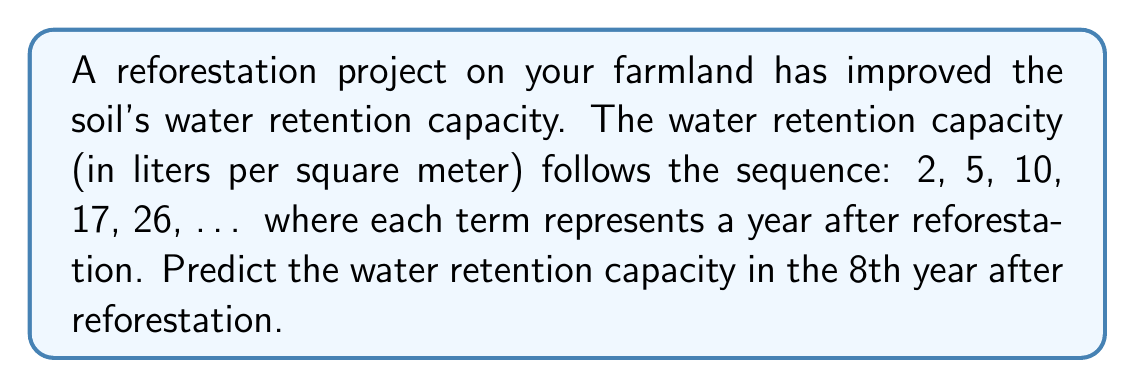Can you answer this question? To solve this problem, let's follow these steps:

1) First, we need to identify the pattern in the given sequence:
   2, 5, 10, 17, 26, ...

2) Let's calculate the differences between consecutive terms:
   5 - 2 = 3
   10 - 5 = 5
   17 - 10 = 7
   26 - 17 = 9

3) We can see that the differences form an arithmetic sequence:
   3, 5, 7, 9, ...
   This sequence has a common difference of 2.

4) This indicates that our original sequence is a quadratic sequence.

5) The general formula for a quadratic sequence is:
   $$a_n = an^2 + bn + c$$
   where $n$ is the term number, and $a$, $b$, and $c$ are constants we need to determine.

6) We can use the first three terms to set up a system of equations:
   $$2 = a(1)^2 + b(1) + c$$
   $$5 = a(2)^2 + b(2) + c$$
   $$10 = a(3)^2 + b(3) + c$$

7) Solving this system (which we'll skip for brevity), we get:
   $$a = 1, b = 0, c = 1$$

8) Therefore, our sequence formula is:
   $$a_n = n^2 + 1$$

9) To find the 8th term, we substitute $n = 8$:
   $$a_8 = 8^2 + 1 = 64 + 1 = 65$$

Thus, in the 8th year after reforestation, the water retention capacity will be 65 liters per square meter.
Answer: 65 liters per square meter 